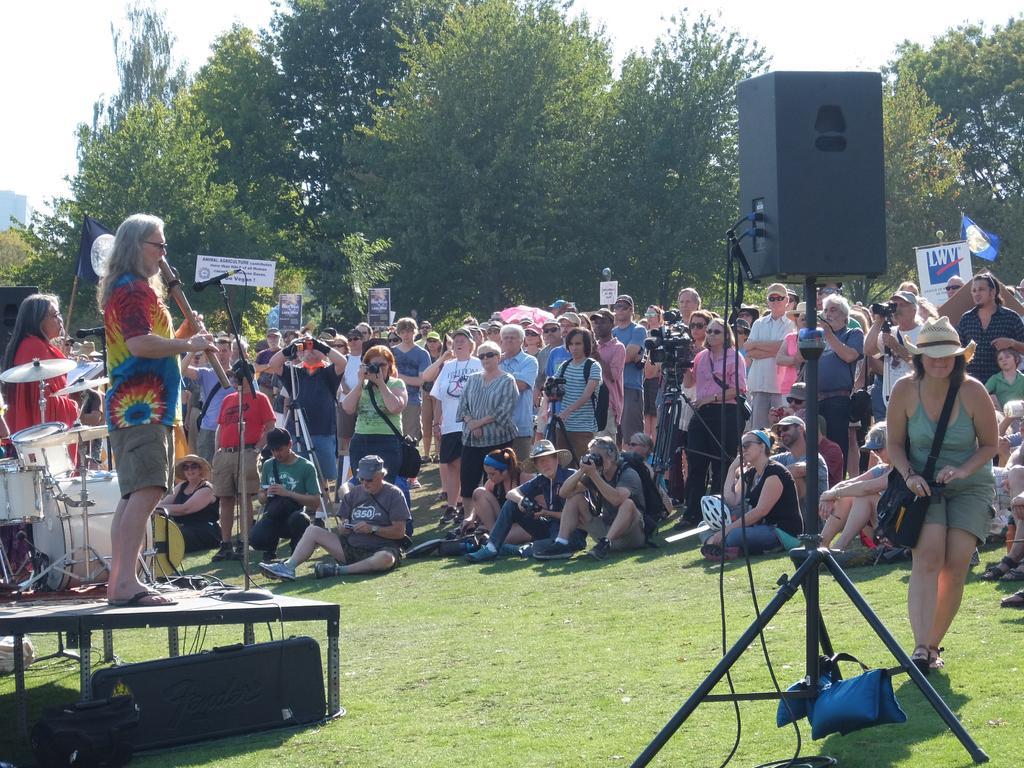How would you summarize this image in a sentence or two? To the left side of the image there is a stage with a man is standing on it. There is a man with colorful shirt is standing and playing flute in front of him there is a mic with a stand. Beside him there are few musical instruments and also there is a lady with red dress. In front of them there are few people sitting and few of them are standing. They are holding the cameras in their hands. To the right side of the image there is a speaker with the stand. In the background there are trees, posters and also there is a sky. 